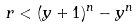<formula> <loc_0><loc_0><loc_500><loc_500>r < ( y + 1 ) ^ { n } - y ^ { n }</formula> 